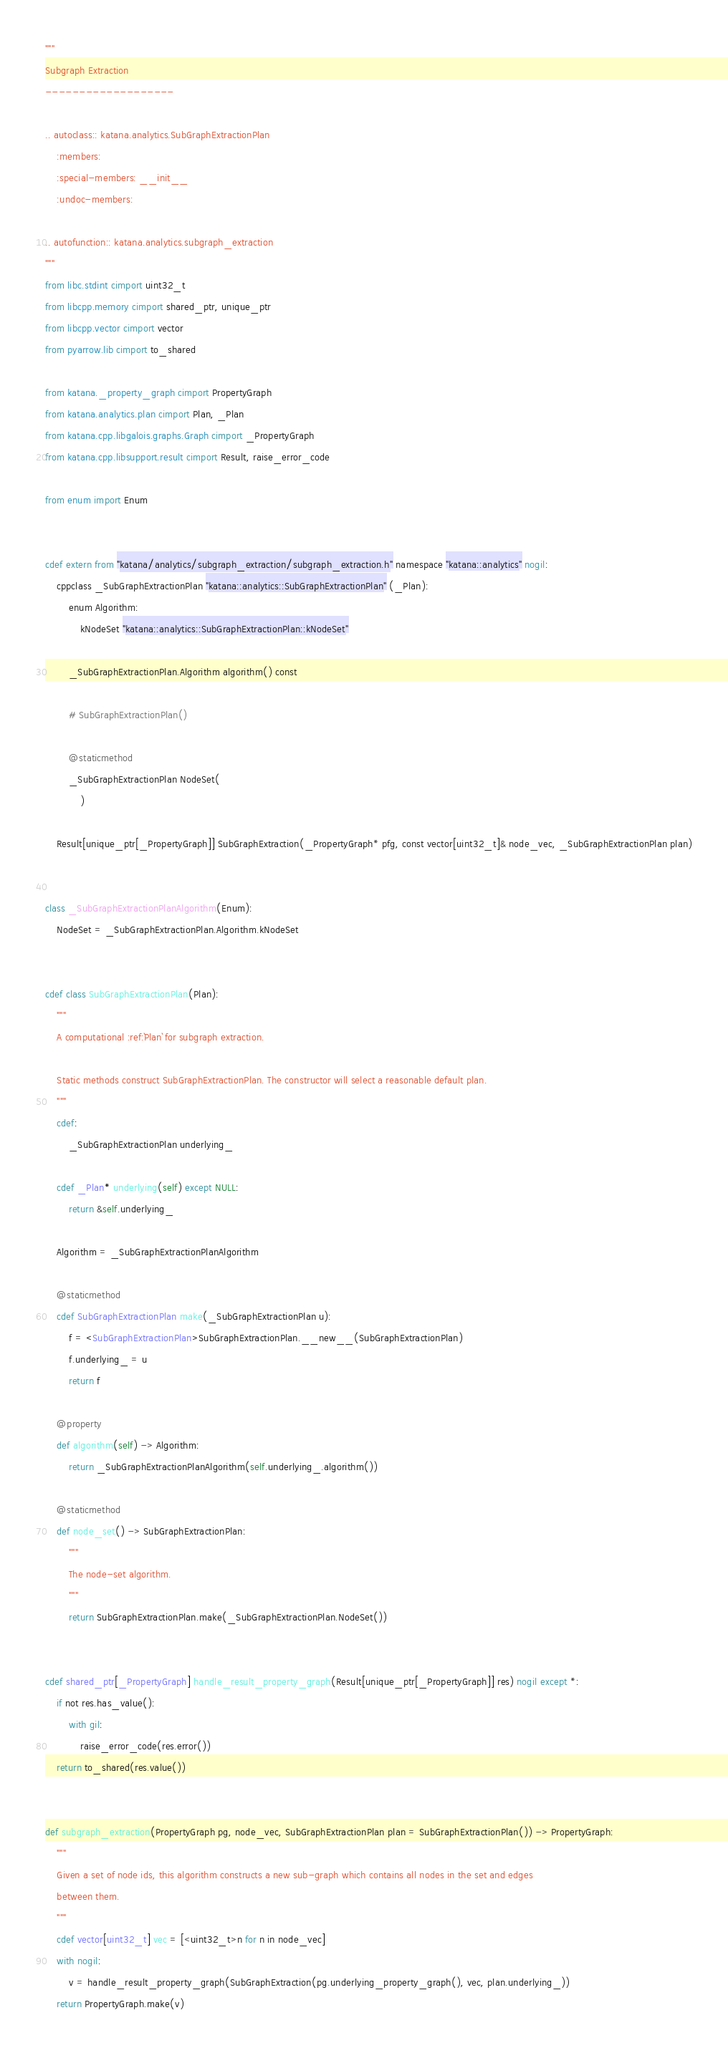Convert code to text. <code><loc_0><loc_0><loc_500><loc_500><_Cython_>"""
Subgraph Extraction
-------------------

.. autoclass:: katana.analytics.SubGraphExtractionPlan
    :members:
    :special-members: __init__
    :undoc-members:

.. autofunction:: katana.analytics.subgraph_extraction
"""
from libc.stdint cimport uint32_t
from libcpp.memory cimport shared_ptr, unique_ptr
from libcpp.vector cimport vector
from pyarrow.lib cimport to_shared

from katana._property_graph cimport PropertyGraph
from katana.analytics.plan cimport Plan, _Plan
from katana.cpp.libgalois.graphs.Graph cimport _PropertyGraph
from katana.cpp.libsupport.result cimport Result, raise_error_code

from enum import Enum


cdef extern from "katana/analytics/subgraph_extraction/subgraph_extraction.h" namespace "katana::analytics" nogil:
    cppclass _SubGraphExtractionPlan "katana::analytics::SubGraphExtractionPlan" (_Plan):
        enum Algorithm:
            kNodeSet "katana::analytics::SubGraphExtractionPlan::kNodeSet"

        _SubGraphExtractionPlan.Algorithm algorithm() const

        # SubGraphExtractionPlan()

        @staticmethod
        _SubGraphExtractionPlan NodeSet(
            )

    Result[unique_ptr[_PropertyGraph]] SubGraphExtraction(_PropertyGraph* pfg, const vector[uint32_t]& node_vec, _SubGraphExtractionPlan plan)


class _SubGraphExtractionPlanAlgorithm(Enum):
    NodeSet = _SubGraphExtractionPlan.Algorithm.kNodeSet


cdef class SubGraphExtractionPlan(Plan):
    """
    A computational :ref:`Plan` for subgraph extraction.

    Static methods construct SubGraphExtractionPlan. The constructor will select a reasonable default plan.
    """
    cdef:
        _SubGraphExtractionPlan underlying_

    cdef _Plan* underlying(self) except NULL:
        return &self.underlying_

    Algorithm = _SubGraphExtractionPlanAlgorithm

    @staticmethod
    cdef SubGraphExtractionPlan make(_SubGraphExtractionPlan u):
        f = <SubGraphExtractionPlan>SubGraphExtractionPlan.__new__(SubGraphExtractionPlan)
        f.underlying_ = u
        return f

    @property
    def algorithm(self) -> Algorithm:
        return _SubGraphExtractionPlanAlgorithm(self.underlying_.algorithm())

    @staticmethod
    def node_set() -> SubGraphExtractionPlan:
        """
        The node-set algorithm.
        """
        return SubGraphExtractionPlan.make(_SubGraphExtractionPlan.NodeSet())


cdef shared_ptr[_PropertyGraph] handle_result_property_graph(Result[unique_ptr[_PropertyGraph]] res) nogil except *:
    if not res.has_value():
        with gil:
            raise_error_code(res.error())
    return to_shared(res.value())


def subgraph_extraction(PropertyGraph pg, node_vec, SubGraphExtractionPlan plan = SubGraphExtractionPlan()) -> PropertyGraph:
    """
    Given a set of node ids, this algorithm constructs a new sub-graph which contains all nodes in the set and edges
    between them.
    """
    cdef vector[uint32_t] vec = [<uint32_t>n for n in node_vec]
    with nogil:
        v = handle_result_property_graph(SubGraphExtraction(pg.underlying_property_graph(), vec, plan.underlying_))
    return PropertyGraph.make(v)
</code> 